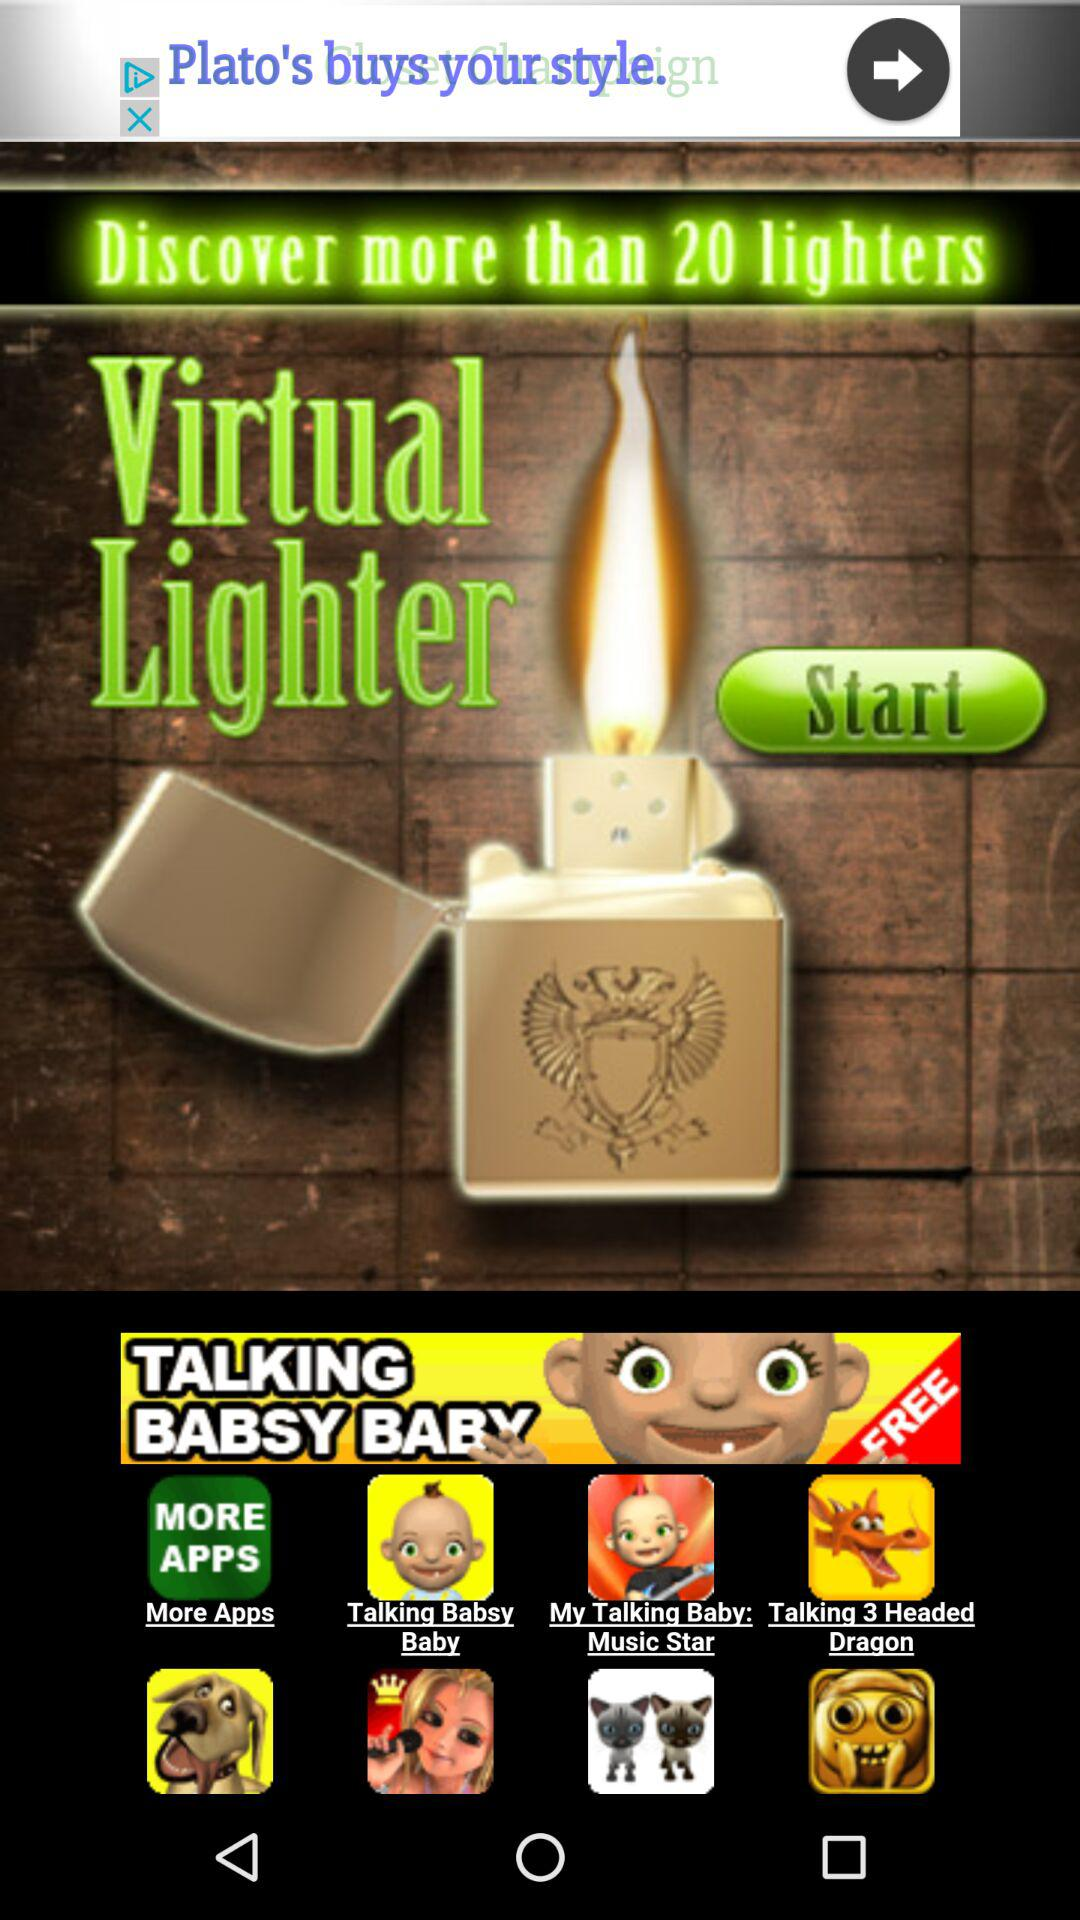What is the application name? The application name is "Virtual Lighter". 